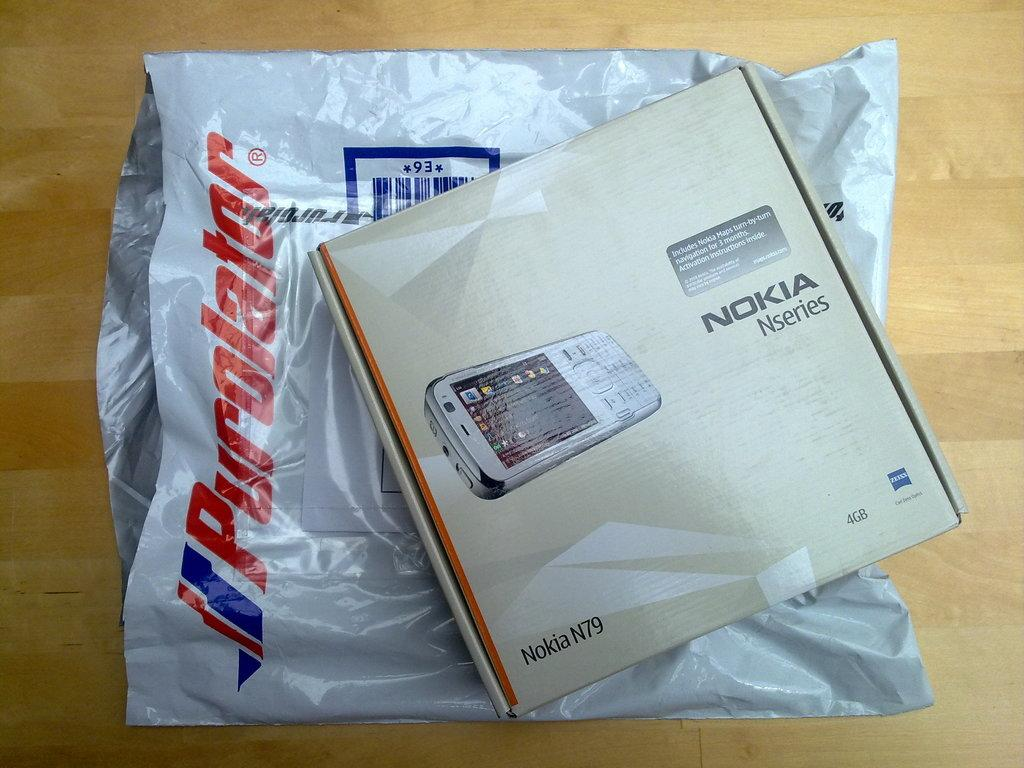<image>
Summarize the visual content of the image. A box for a Nokia phone has arrived in a post bag. 